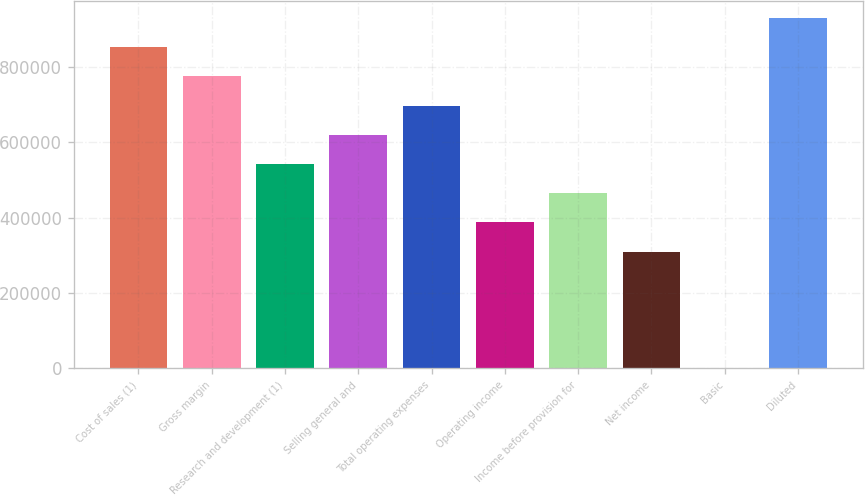Convert chart. <chart><loc_0><loc_0><loc_500><loc_500><bar_chart><fcel>Cost of sales (1)<fcel>Gross margin<fcel>Research and development (1)<fcel>Selling general and<fcel>Total operating expenses<fcel>Operating income<fcel>Income before provision for<fcel>Net income<fcel>Basic<fcel>Diluted<nl><fcel>852254<fcel>774776<fcel>542343<fcel>619821<fcel>697298<fcel>387388<fcel>464866<fcel>309911<fcel>0.36<fcel>929731<nl></chart> 